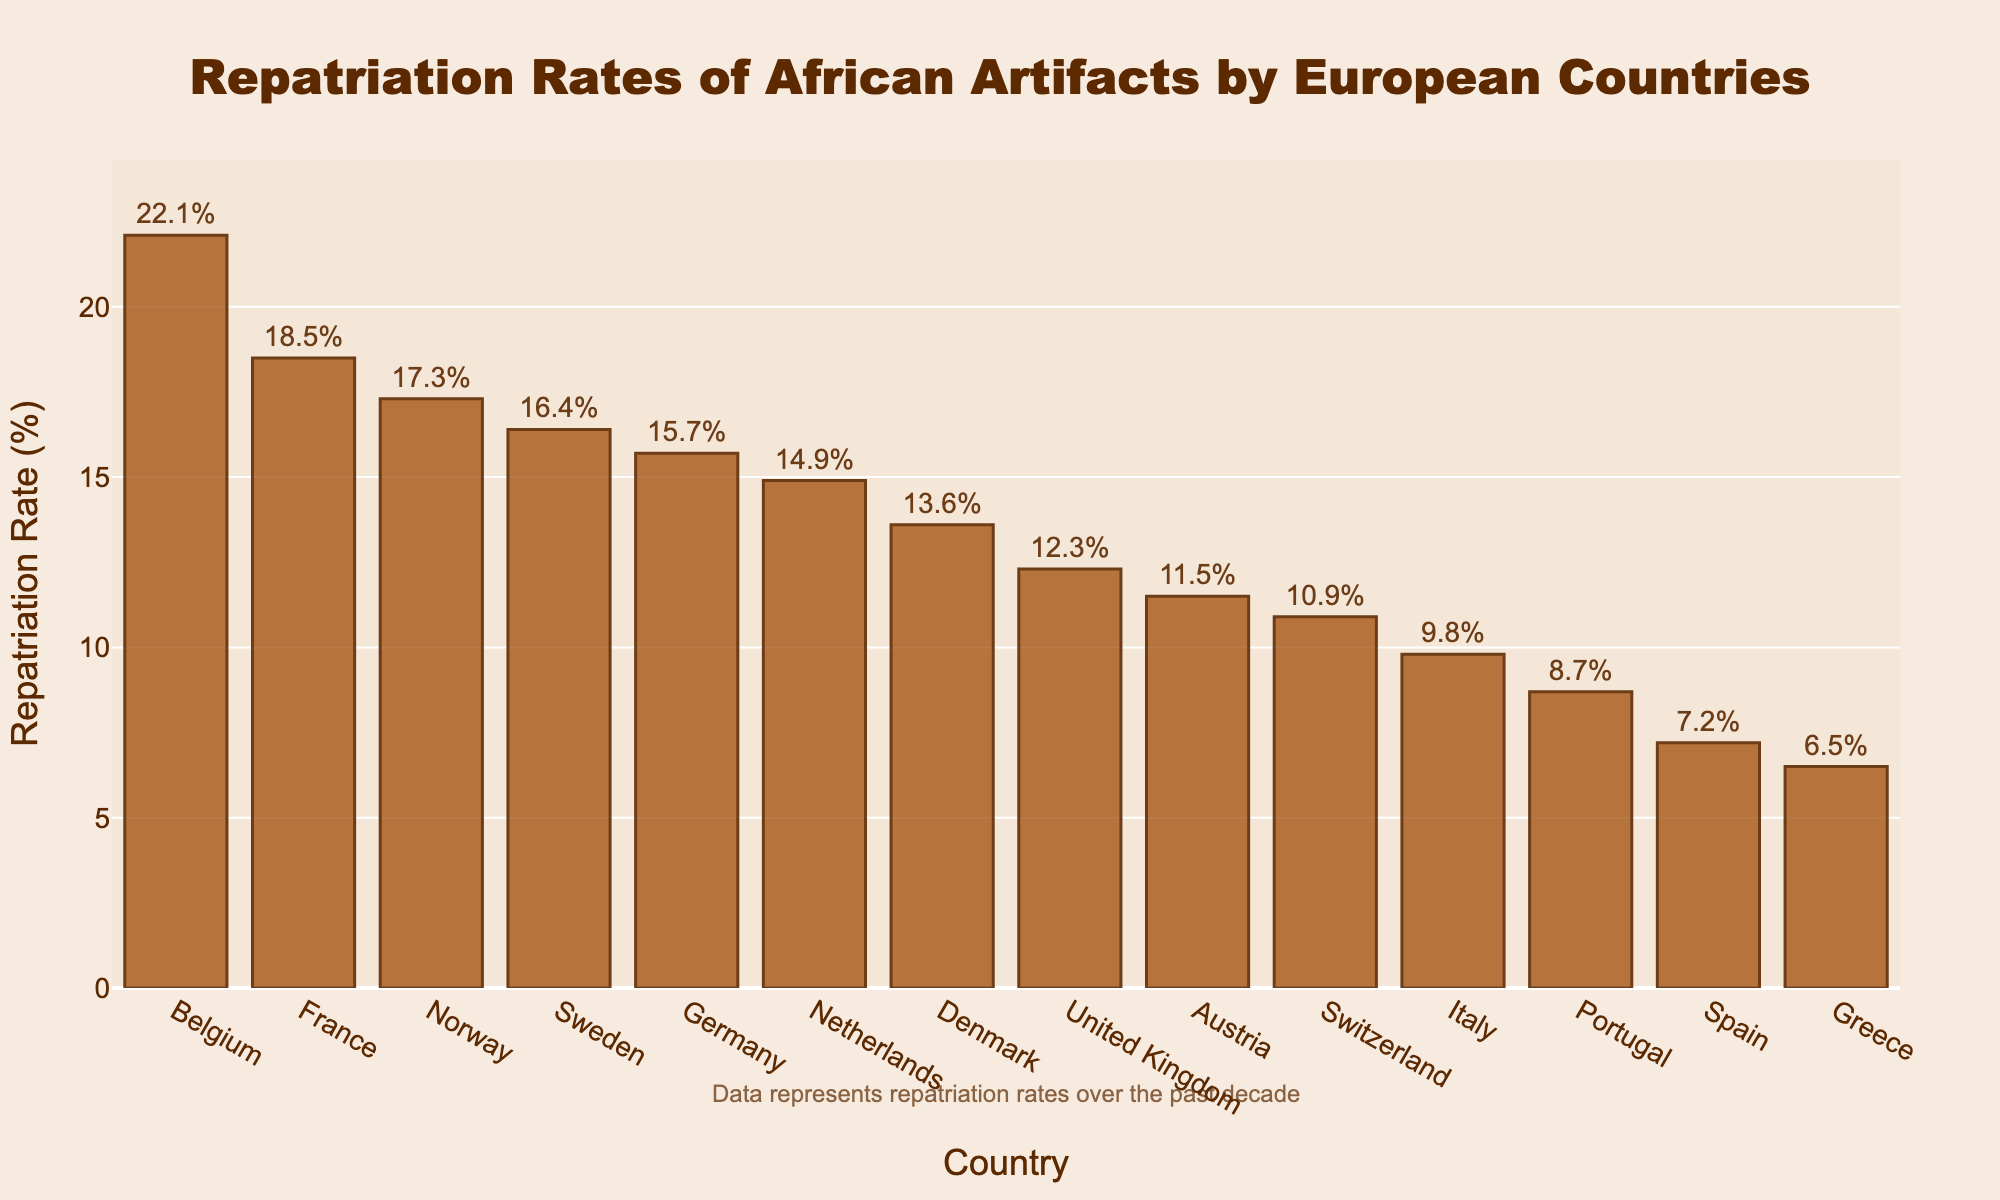Which country had the highest repatriation rate of African artifacts? By looking at the bar chart, we can see that Belgium has the tallest bar, indicating the highest repatriation rate.
Answer: Belgium Which country had the lowest repatriation rate of African artifacts? Observing the chart, the bar for Greece is the shortest, suggesting the lowest repatriation rate.
Answer: Greece How much higher is Belgium’s repatriation rate compared to the United Kingdom’s? Belgium's rate is 22.1% and the United Kingdom's is 12.3%. Subtracting these gives us 22.1 - 12.3 = 9.8.
Answer: 9.8% Among the countries listed, which one had a repatriation rate closest to 15%? The chart shows that the Netherlands has a rate of 14.9%, which is the closest to 15%.
Answer: Netherlands How does the repatriation rate of France compare to that of Germany? France has a repatriation rate of 18.5% and Germany has 15.7%. Since 18.5 is greater than 15.7, France has a higher repatriation rate.
Answer: France What is the average repatriation rate of Norway, Sweden, and Denmark? Adding the rates: 17.3 (Norway) + 16.4 (Sweden) + 13.6 (Denmark) = 47.3. Dividing by 3 gives 47.3 / 3 = 15.77.
Answer: 15.77% Which countries have a repatriation rate higher than 15% but lower than 20%? By examining the chart, the countries within this range are France (18.5%), Germany (15.7%), Sweden (16.4%), and Norway (17.3%).
Answer: France, Germany, Sweden, Norway What is the combined repatriation rate for Portugal and Spain? Adding the rates for Portugal (8.7%) and Spain (7.2%) gives us 8.7 + 7.2 = 15.9.
Answer: 15.9% Compare the repatriation rates of Italy and Switzerland. Which country has a higher rate and by how much? Italy has a rate of 9.8% and Switzerland has 10.9%. Subtracting these gives us 10.9 - 9.8 = 1.1. Switzerland’s rate is 1.1% higher than Italy’s.
Answer: Switzerland, 1.1% Which country has a repatriation rate just under 10%? The bar chart shows that Italy has a repatriation rate of 9.8%, which is just under 10%.
Answer: Italy 